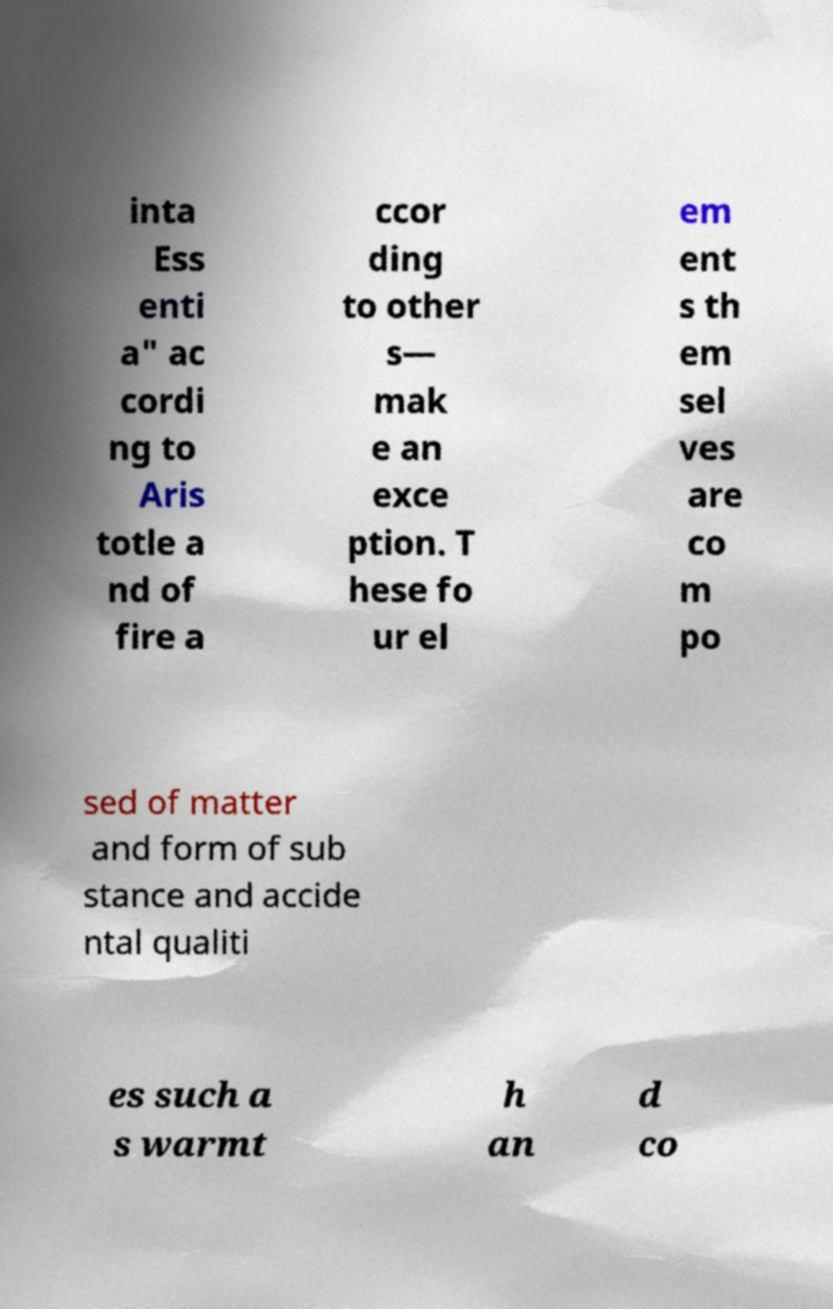There's text embedded in this image that I need extracted. Can you transcribe it verbatim? inta Ess enti a" ac cordi ng to Aris totle a nd of fire a ccor ding to other s— mak e an exce ption. T hese fo ur el em ent s th em sel ves are co m po sed of matter and form of sub stance and accide ntal qualiti es such a s warmt h an d co 